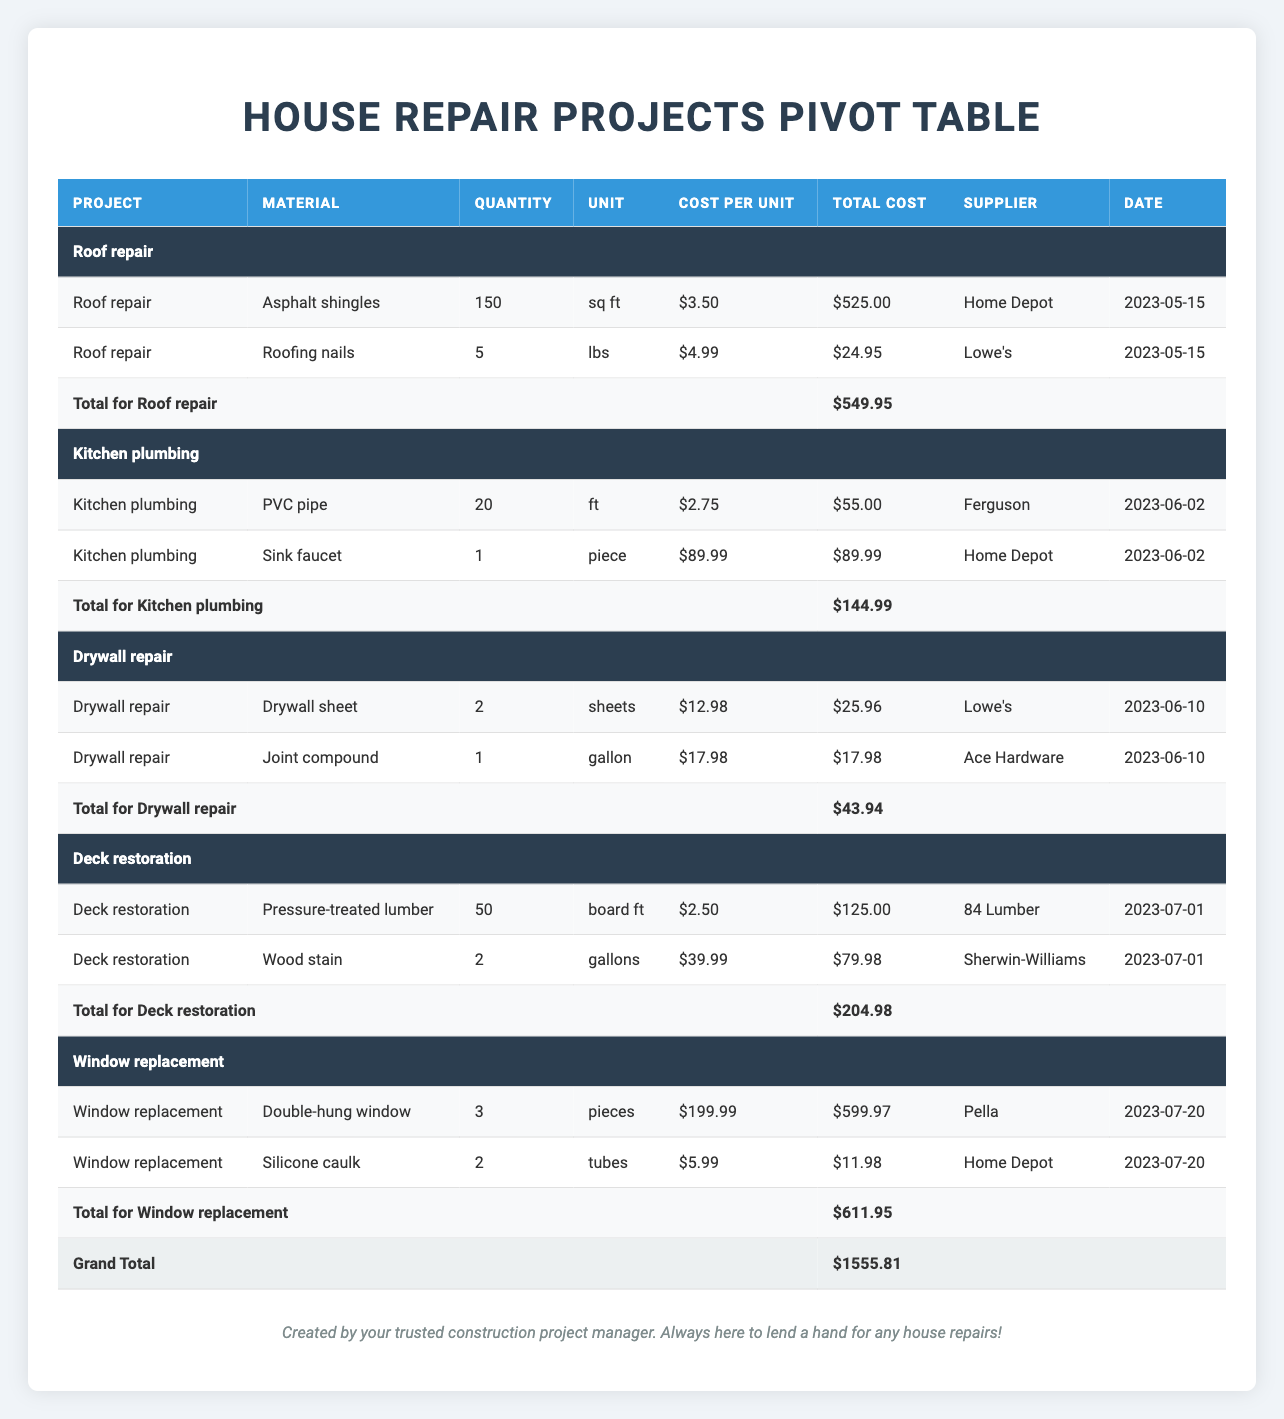What is the total cost of materials for the Roof repair project? The total cost of the Roof repair project is summarized in the table under the row labeled "Total for Roof repair". This row indicates a total cost of $549.95.
Answer: 549.95 How many pounds of Roofing nails were used in the Roof repair project? Looking at the Roof repair section, the entry for Roofing nails shows a quantity of 5 lbs.
Answer: 5 Which supplier provided the Sink faucet for the Kitchen plumbing project? The row corresponding to the Sink faucet in the Kitchen plumbing project indicates that it was supplied by Home Depot.
Answer: Home Depot What is the average cost per unit of all materials used in the Drywall repair project? To find the average cost per unit for the Drywall repair project, we first look at the costs per unit (12.98 for Drywall sheet and 17.98 for Joint compound), which total to 30.96. Since there are 2 materials, the average cost per unit is 30.96 divided by 2, resulting in 15.48.
Answer: 15.48 Is the total cost of materials for the Deck restoration project less than $300? The total cost for the Deck restoration project is $204.98, which is less than $300. This can be verified in the total row for Deck restoration.
Answer: Yes What is the total quantity of Double-hung windows and Silicone caulk used in the Window replacement project? For the Window replacement project, there are 3 Double-hung windows and 2 tubes of Silicone caulk. Adding these quantities gives us a total of 3 + 2 = 5.
Answer: 5 What is the total expenditure on materials for all projects combined? To get the total expenditure, we sum the total costs across all project total rows: 
Roof repair ($549.95) + Kitchen plumbing ($144.99) + Drywall repair ($43.94) + Deck restoration ($204.98) + Window replacement ($611.95) = $1555.81.
Answer: 1555.81 Did any material cost over $200 used in any of the projects? Yes, checking the Window replacement project, the Double-hung window costs $199.99, which is the highest individual cost, while the total for the project surpasses $200. Therefore, yes, there are costs of materials that are individually significant.
Answer: Yes How much was spent on materials for Kitchen plumbing compared to Drywall repair? The total cost for Kitchen plumbing is $144.99, and for Drywall repair, it's $43.94. The difference is obtained by subtracting Drywall's total from Kitchen plumbing's, resulting in $144.99 - $43.94 = $101.05 spent more on Kitchen plumbing than on Drywall repair.
Answer: 101.05 